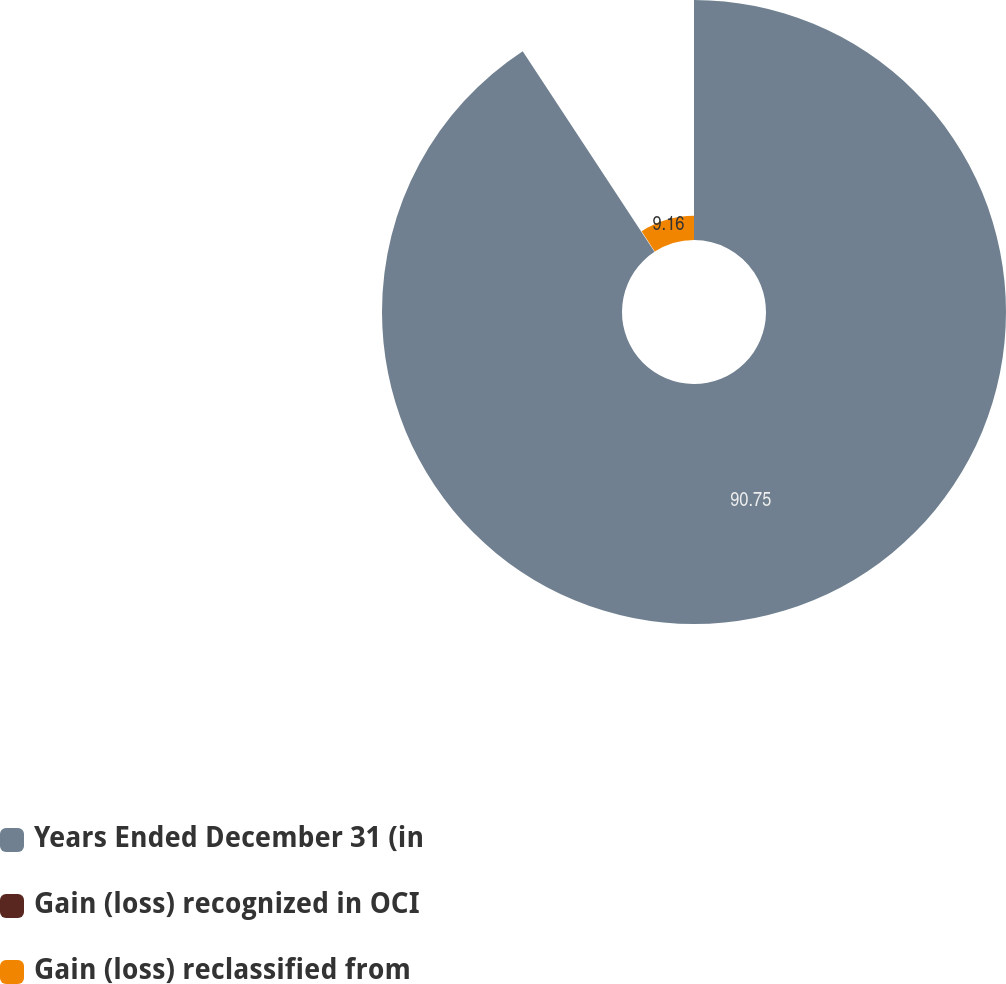Convert chart. <chart><loc_0><loc_0><loc_500><loc_500><pie_chart><fcel>Years Ended December 31 (in<fcel>Gain (loss) recognized in OCI<fcel>Gain (loss) reclassified from<nl><fcel>90.75%<fcel>0.09%<fcel>9.16%<nl></chart> 